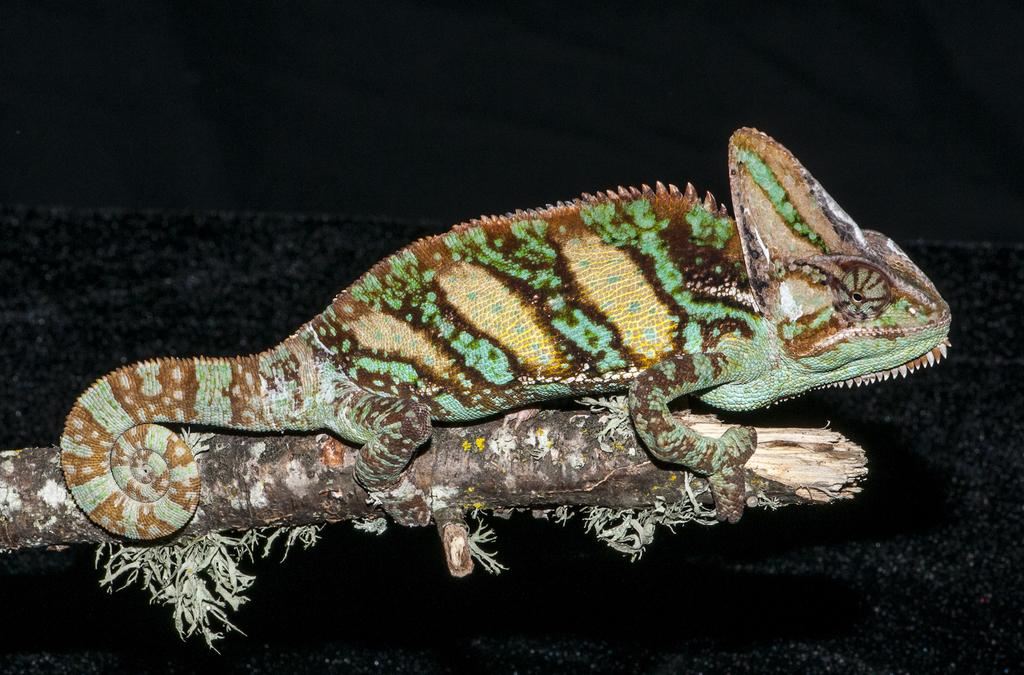What type of animal is in the image? There is a reptile in the image. Where is the reptile located? The reptile is on a branch. What can be observed about the background of the image? The background of the image is dark. What type of yam is growing in the field in the image? There is no field or yam present in the image; it features a reptile on a branch with a dark background. 